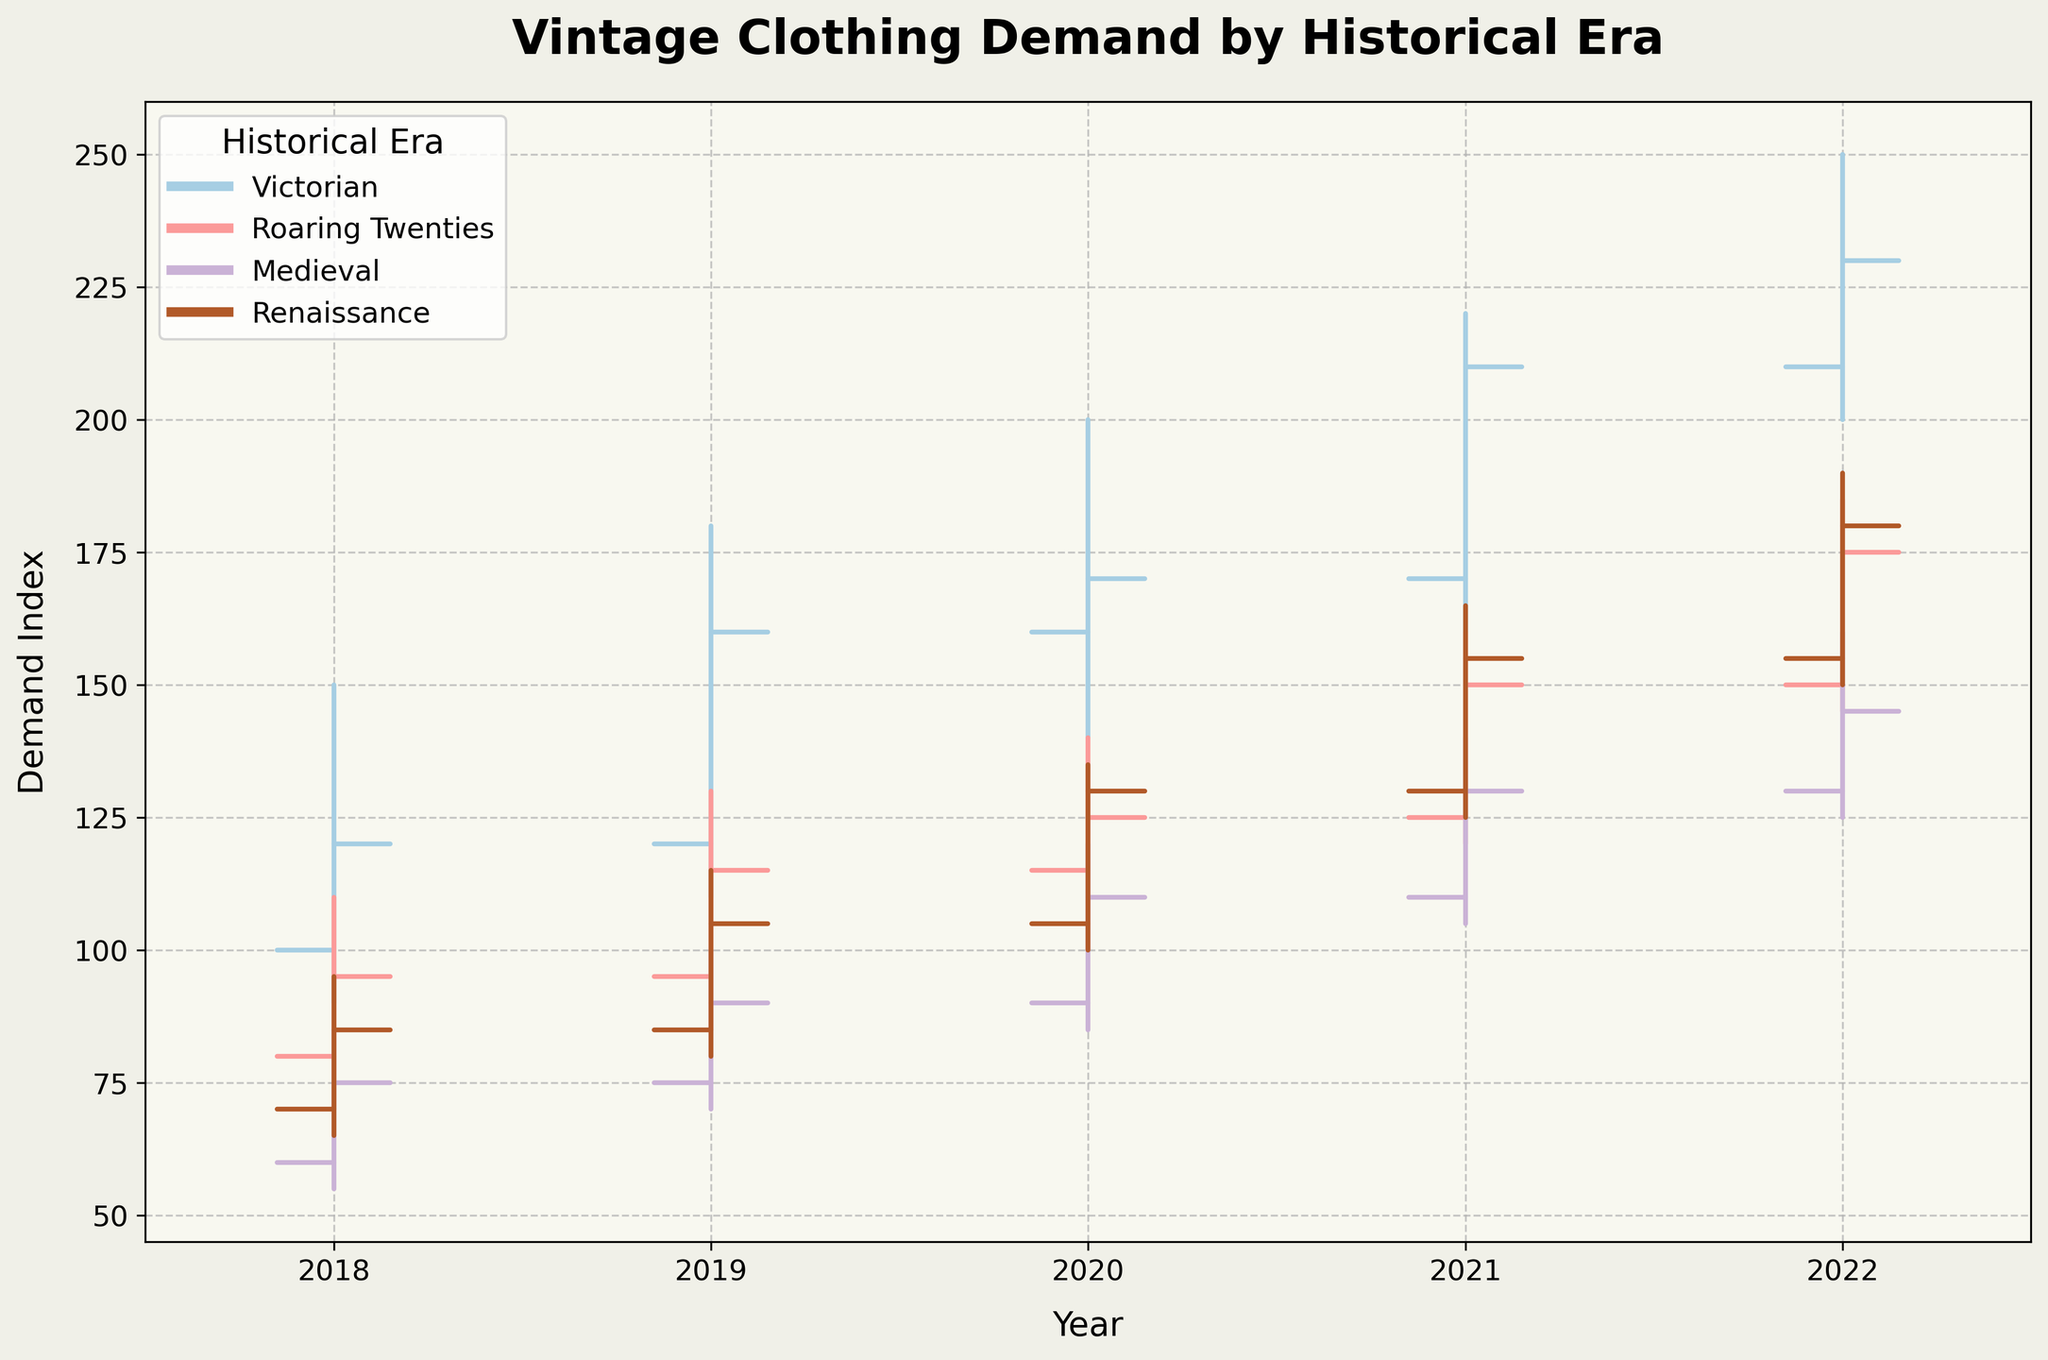What historical era has the highest demand index in 2021? Looking at the OHLC bars for 2021, the highest 'High' value is for the Victorian era, which reaches 220.
Answer: Victorian How did the demand for Medieval era clothing change from 2020 to 2021? In 2020, the 'Close' for Medieval is 110, and in 2021, it is 130. Hence, it increased by 20 points.
Answer: Increased by 20 points Which era saw the largest increase in its 'Close' value from 2018 to 2019? Comparing the 'Close' values: Victorian (120 to 160), Roaring Twenties (95 to 115), Medieval (75 to 90), Renaissance (85 to 105). The Victorian era has the largest increase of 40 points.
Answer: Victorian During which year did the Roaring Twenties era have its lowest 'Low' value? The lowest 'Low' value for Roaring Twenties is 70 in 2018.
Answer: 2018 What is the average 'High' value for the Renaissance era from 2018 to 2022? Adding the 'High' values: 95 (2018) + 115 (2019) + 135 (2020) + 165 (2021) + 190 (2022) gives a total of 700. Dividing by 5, the average is 140.
Answer: 140 How does the 2022 'Open' value for the Victorian era compare to its 2021 'Close' value? The 'Open' in 2022 is 210, and the 'Close' in 2021 is 210, so they are equal.
Answer: Equal Which era experienced the smallest range (High-Low) in 2020? The range for each era in 2020: Victorian (60), Roaring Twenties (40), Medieval (35), Renaissance (35). Both Medieval and Renaissance have the smallest range of 35.
Answer: Medieval and Renaissance How did the 'Close' value for Roaring Twenties change from 2021 to 2022? The 'Close' value for the Roaring Twenties in 2021 is 150 and in 2022 it is 175, showing an increase of 25 points.
Answer: Increased by 25 points During which year did the Victorian era have its highest 'High' value, and what was it? The highest 'High' value for the Victorian era is 250, which occurs in 2022.
Answer: 2022, 250 